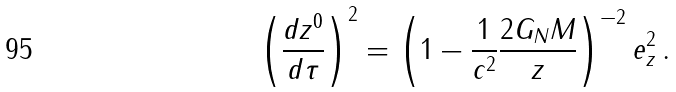<formula> <loc_0><loc_0><loc_500><loc_500>\left ( \frac { d z ^ { 0 } } { d \tau } \right ) ^ { 2 } = \left ( 1 - \frac { 1 } { c ^ { 2 } } \frac { 2 G _ { N } M } { z } \right ) ^ { - 2 } e _ { z } ^ { 2 } \, .</formula> 